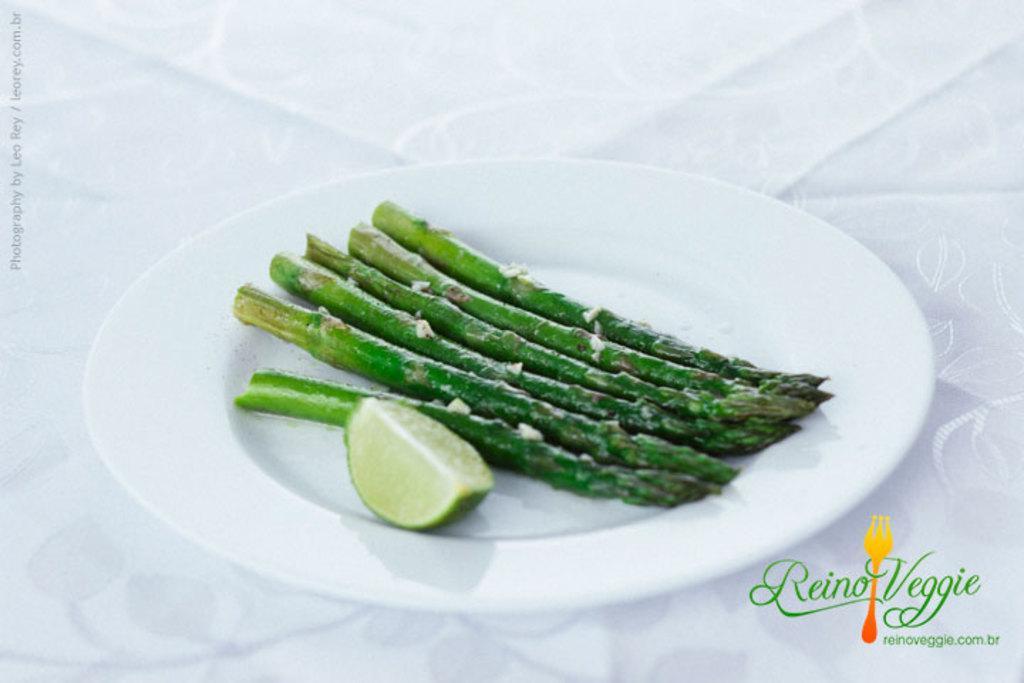How would you summarize this image in a sentence or two? In the picture I can see some green color sticks and a slice of lemon are kept on the white color plate which is placed on the white color surface. Here I can see watermark at the left corner of the image and at the bottom right side of the image. 